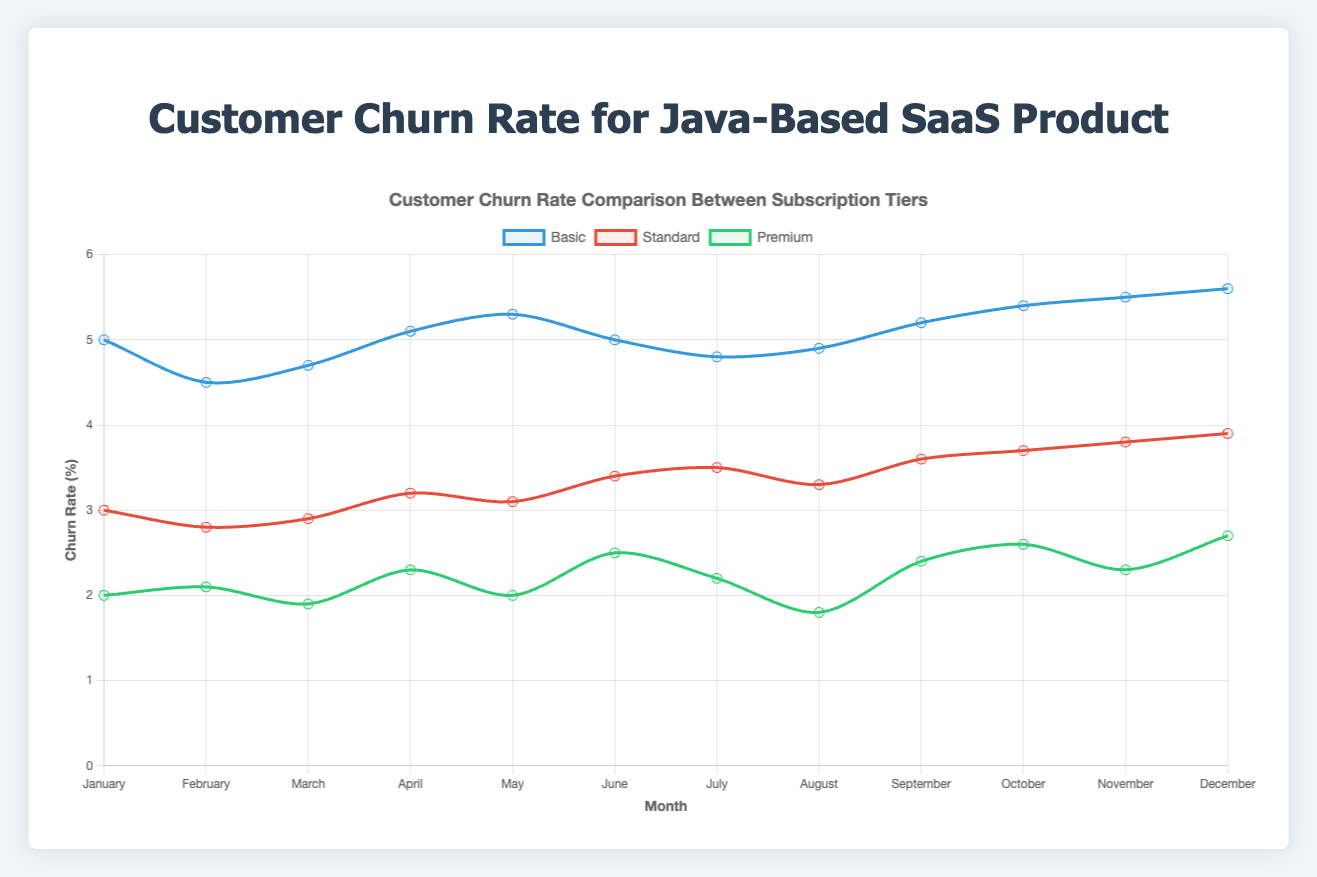What was the churn rate for the Basic tier in May? Looking at the 'Basic' line on the chart and finding the data point for May, the churn rate is 5.3%.
Answer: 5.3% Which subscription tier had the highest churn rate in December? By examining the December data points for all three lines, the Basic tier had the highest churn rate with 5.6%.
Answer: Basic What is the average churn rate for the Premium tier over the entire year? Adding up the monthly churn rates for Premium (2.0 + 2.1 + 1.9 + 2.3 + 2.0 + 2.5 + 2.2 + 1.8 + 2.4 + 2.6 + 2.3 + 2.7) gives 28.8, and dividing by 12 months gives an average churn rate of 2.4%.
Answer: 2.4% In which month does the Standard tier surpass the Basic tier's churn rate for the first time? Checking month by month in the chart, June shows the Standard tier at 3.4 while the Basic tier is at 3.0, so June is the first month the Standard surpasses the Basic tier.
Answer: June Which month shows the smallest difference in churn rate between the Basic and Premium tiers? Calculating the differences for each month: January is 3.0, February is 2.4, March is 2.8, April is 2.8, May is 3.3, June is 2.5, July is 2.6, August is 3.1, September is 2.8, October is 2.8, November is 3.2, and December is 2.9. February, with a difference of 2.4%, is the smallest.
Answer: February How did the churn rate trend for the Standard tier change from January to December? From January to December, the Standard tier's churn rate increased from 3.0% to 3.9%.
Answer: Increased What is the total churn rate for the Basic tier from the first half-year (January to June)? Summing up January to June churn rates for the Basic tier (5.0 + 4.5 + 4.7 + 5.1 + 5.3 + 5.0) gives a total of 29.6%.
Answer: 29.6% Compare the July churn rates across all subscription tiers. Which tier has the lowest churn rate? In July, Basic is 4.8, Standard is 3.5, and Premium is 2.2. The Premium tier has the lowest churn rate.
Answer: Premium What is the median value of the churn rates for the Standard tier? Sorting the Standard churn rates (2.8, 2.9, 3.0, 3.1, 3.2, 3.3, 3.4, 3.5, 3.6, 3.7, 3.8, 3.9), the middle values are 3.35, so the median is (3.35).
Answer: 3.35 During which month did the Premium tier experience its maximum churn rate, and what was that rate? Looking at the highest point on the Premium line, December shows the highest churn rate at 2.7%.
Answer: December, 2.7% 